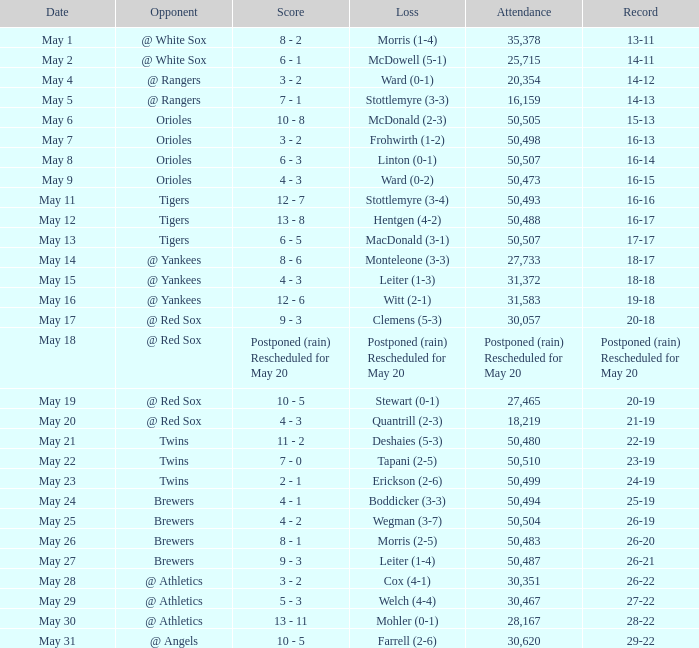What was the score of the game played on May 9? 4 - 3. 